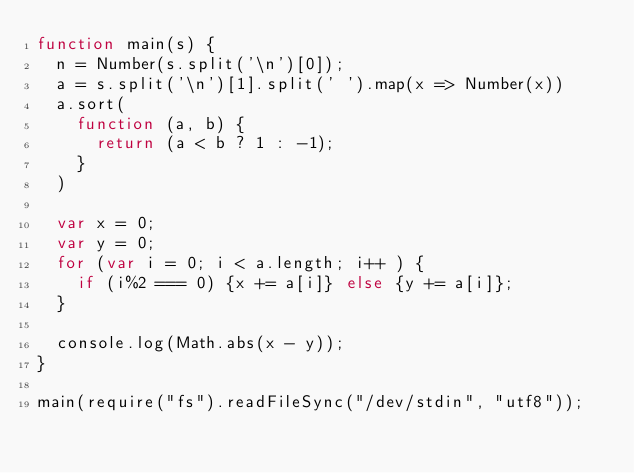<code> <loc_0><loc_0><loc_500><loc_500><_JavaScript_>function main(s) {
	n = Number(s.split('\n')[0]);
	a = s.split('\n')[1].split(' ').map(x => Number(x))
	a.sort(
		function (a, b) {
			return (a < b ? 1 : -1);
		}
	)

	var x = 0;
	var y = 0;
	for (var i = 0; i < a.length; i++ ) {
		if (i%2 === 0) {x += a[i]} else {y += a[i]};
	}

	console.log(Math.abs(x - y));
}

main(require("fs").readFileSync("/dev/stdin", "utf8"));
</code> 